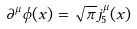Convert formula to latex. <formula><loc_0><loc_0><loc_500><loc_500>\partial ^ { \mu } \phi ( x ) = \sqrt { \pi } j _ { 5 } ^ { \mu } ( x )</formula> 